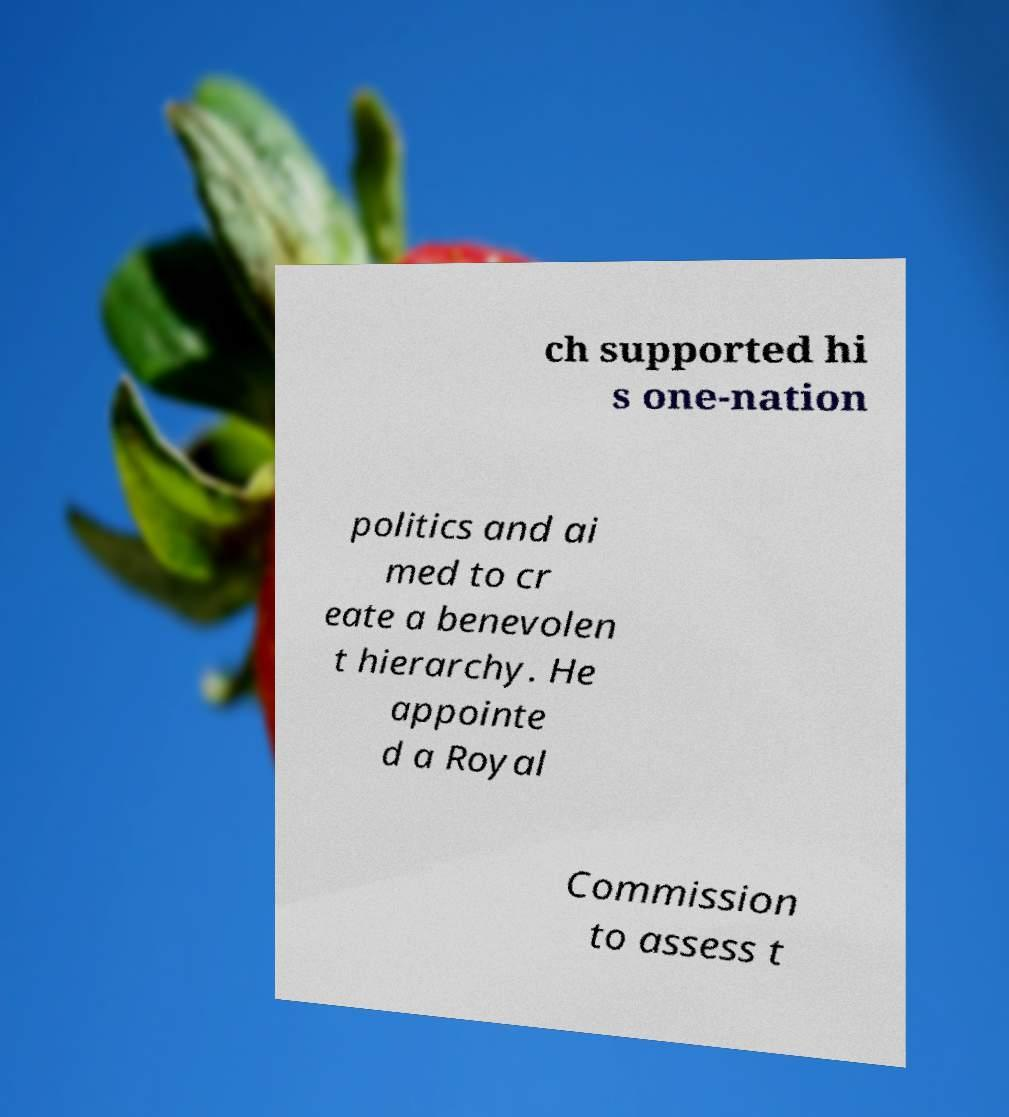Please read and relay the text visible in this image. What does it say? ch supported hi s one-nation politics and ai med to cr eate a benevolen t hierarchy. He appointe d a Royal Commission to assess t 